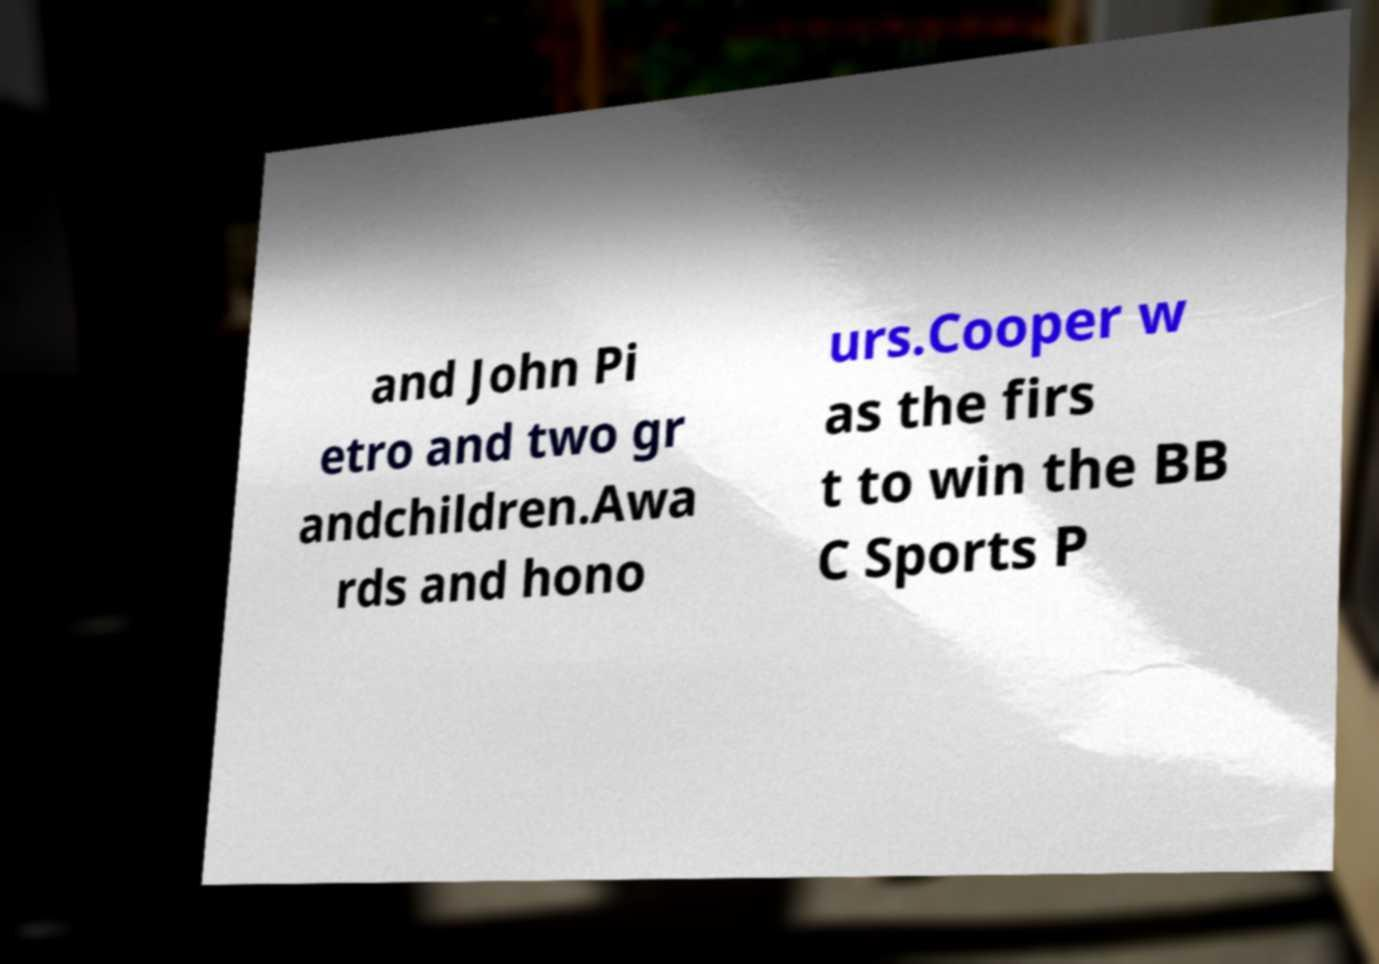What messages or text are displayed in this image? I need them in a readable, typed format. and John Pi etro and two gr andchildren.Awa rds and hono urs.Cooper w as the firs t to win the BB C Sports P 